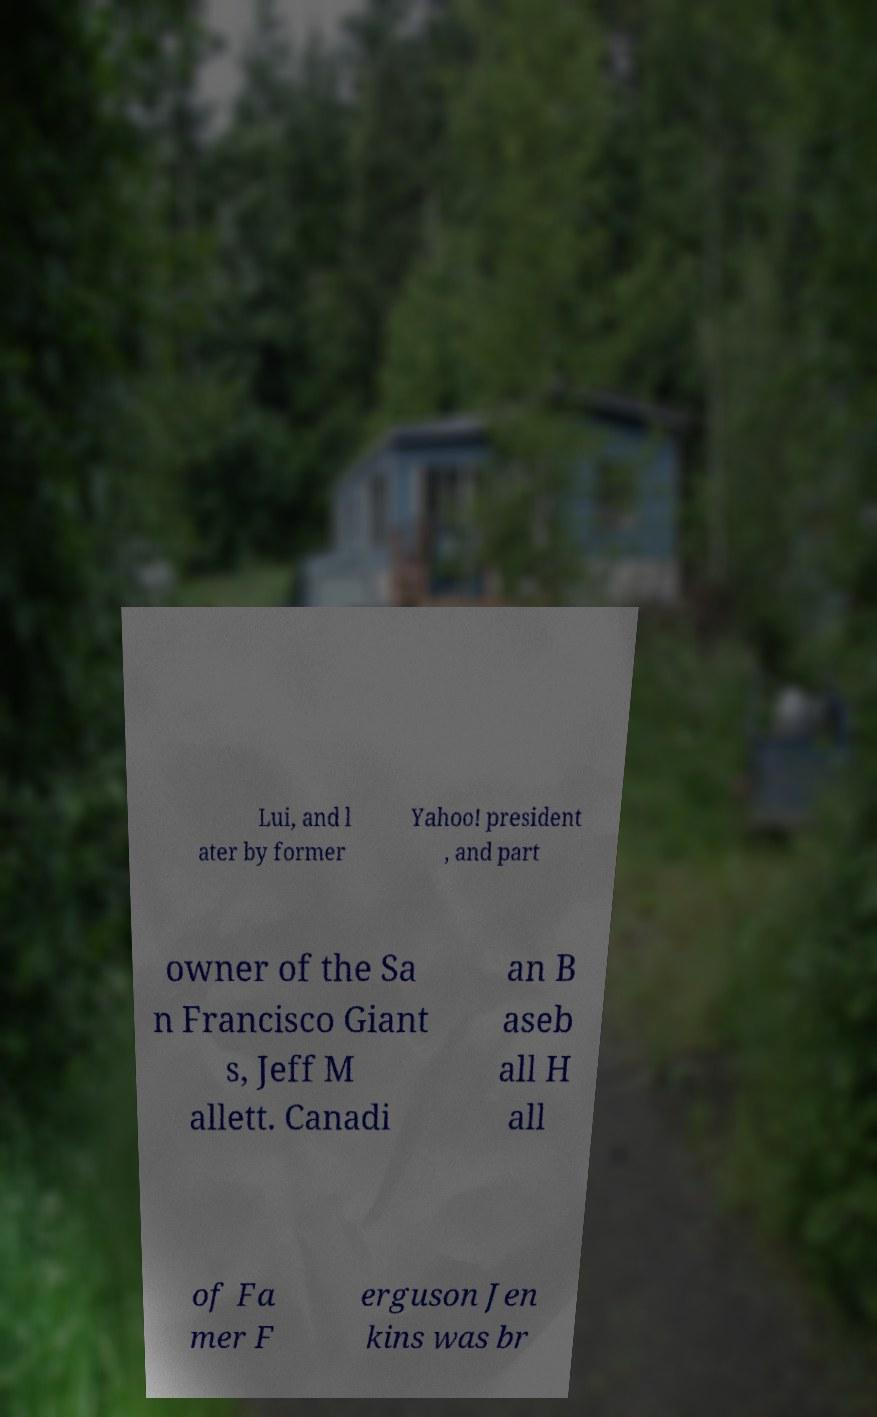I need the written content from this picture converted into text. Can you do that? Lui, and l ater by former Yahoo! president , and part owner of the Sa n Francisco Giant s, Jeff M allett. Canadi an B aseb all H all of Fa mer F erguson Jen kins was br 